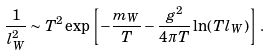Convert formula to latex. <formula><loc_0><loc_0><loc_500><loc_500>\frac { 1 } { l _ { W } ^ { 2 } } \sim T ^ { 2 } \exp \left [ - \frac { m _ { W } } T - \frac { g ^ { 2 } } { 4 \pi T } \ln ( T l _ { W } ) \right ] \, .</formula> 